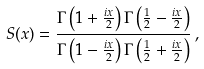<formula> <loc_0><loc_0><loc_500><loc_500>S ( x ) = \frac { \Gamma \left ( 1 + \frac { i x } { 2 } \right ) \Gamma \left ( \frac { 1 } { 2 } - \frac { i x } { 2 } \right ) } { \Gamma \left ( 1 - \frac { i x } { 2 } \right ) \Gamma \left ( \frac { 1 } { 2 } + \frac { i x } { 2 } \right ) } \, ,</formula> 